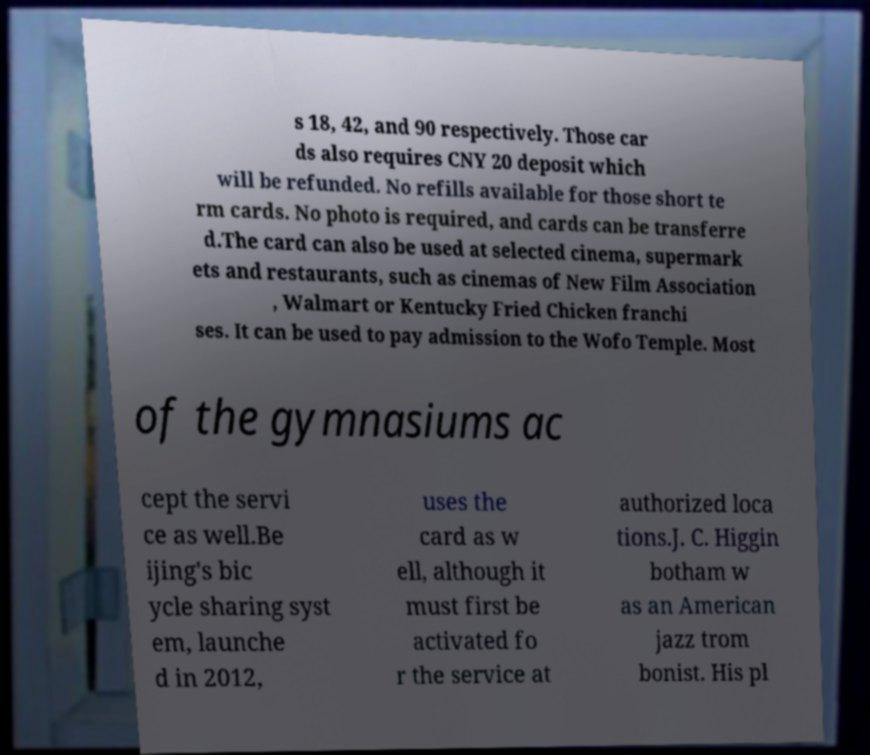Please identify and transcribe the text found in this image. s 18, 42, and 90 respectively. Those car ds also requires CNY 20 deposit which will be refunded. No refills available for those short te rm cards. No photo is required, and cards can be transferre d.The card can also be used at selected cinema, supermark ets and restaurants, such as cinemas of New Film Association , Walmart or Kentucky Fried Chicken franchi ses. It can be used to pay admission to the Wofo Temple. Most of the gymnasiums ac cept the servi ce as well.Be ijing's bic ycle sharing syst em, launche d in 2012, uses the card as w ell, although it must first be activated fo r the service at authorized loca tions.J. C. Higgin botham w as an American jazz trom bonist. His pl 